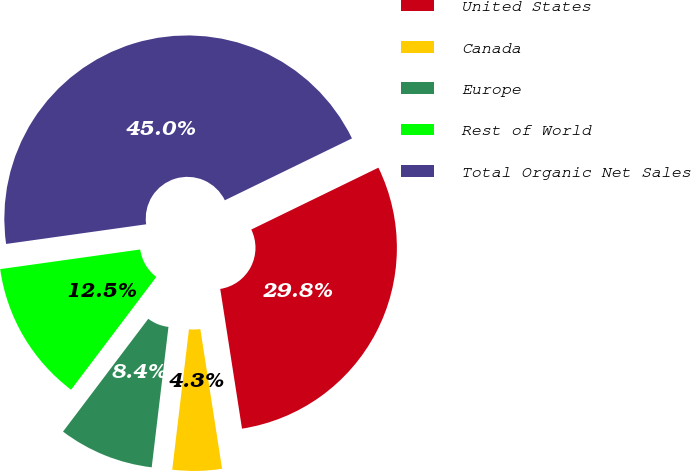<chart> <loc_0><loc_0><loc_500><loc_500><pie_chart><fcel>United States<fcel>Canada<fcel>Europe<fcel>Rest of World<fcel>Total Organic Net Sales<nl><fcel>29.75%<fcel>4.35%<fcel>8.41%<fcel>12.48%<fcel>45.01%<nl></chart> 